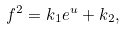Convert formula to latex. <formula><loc_0><loc_0><loc_500><loc_500>f ^ { 2 } = k _ { 1 } e ^ { u } + k _ { 2 } ,</formula> 